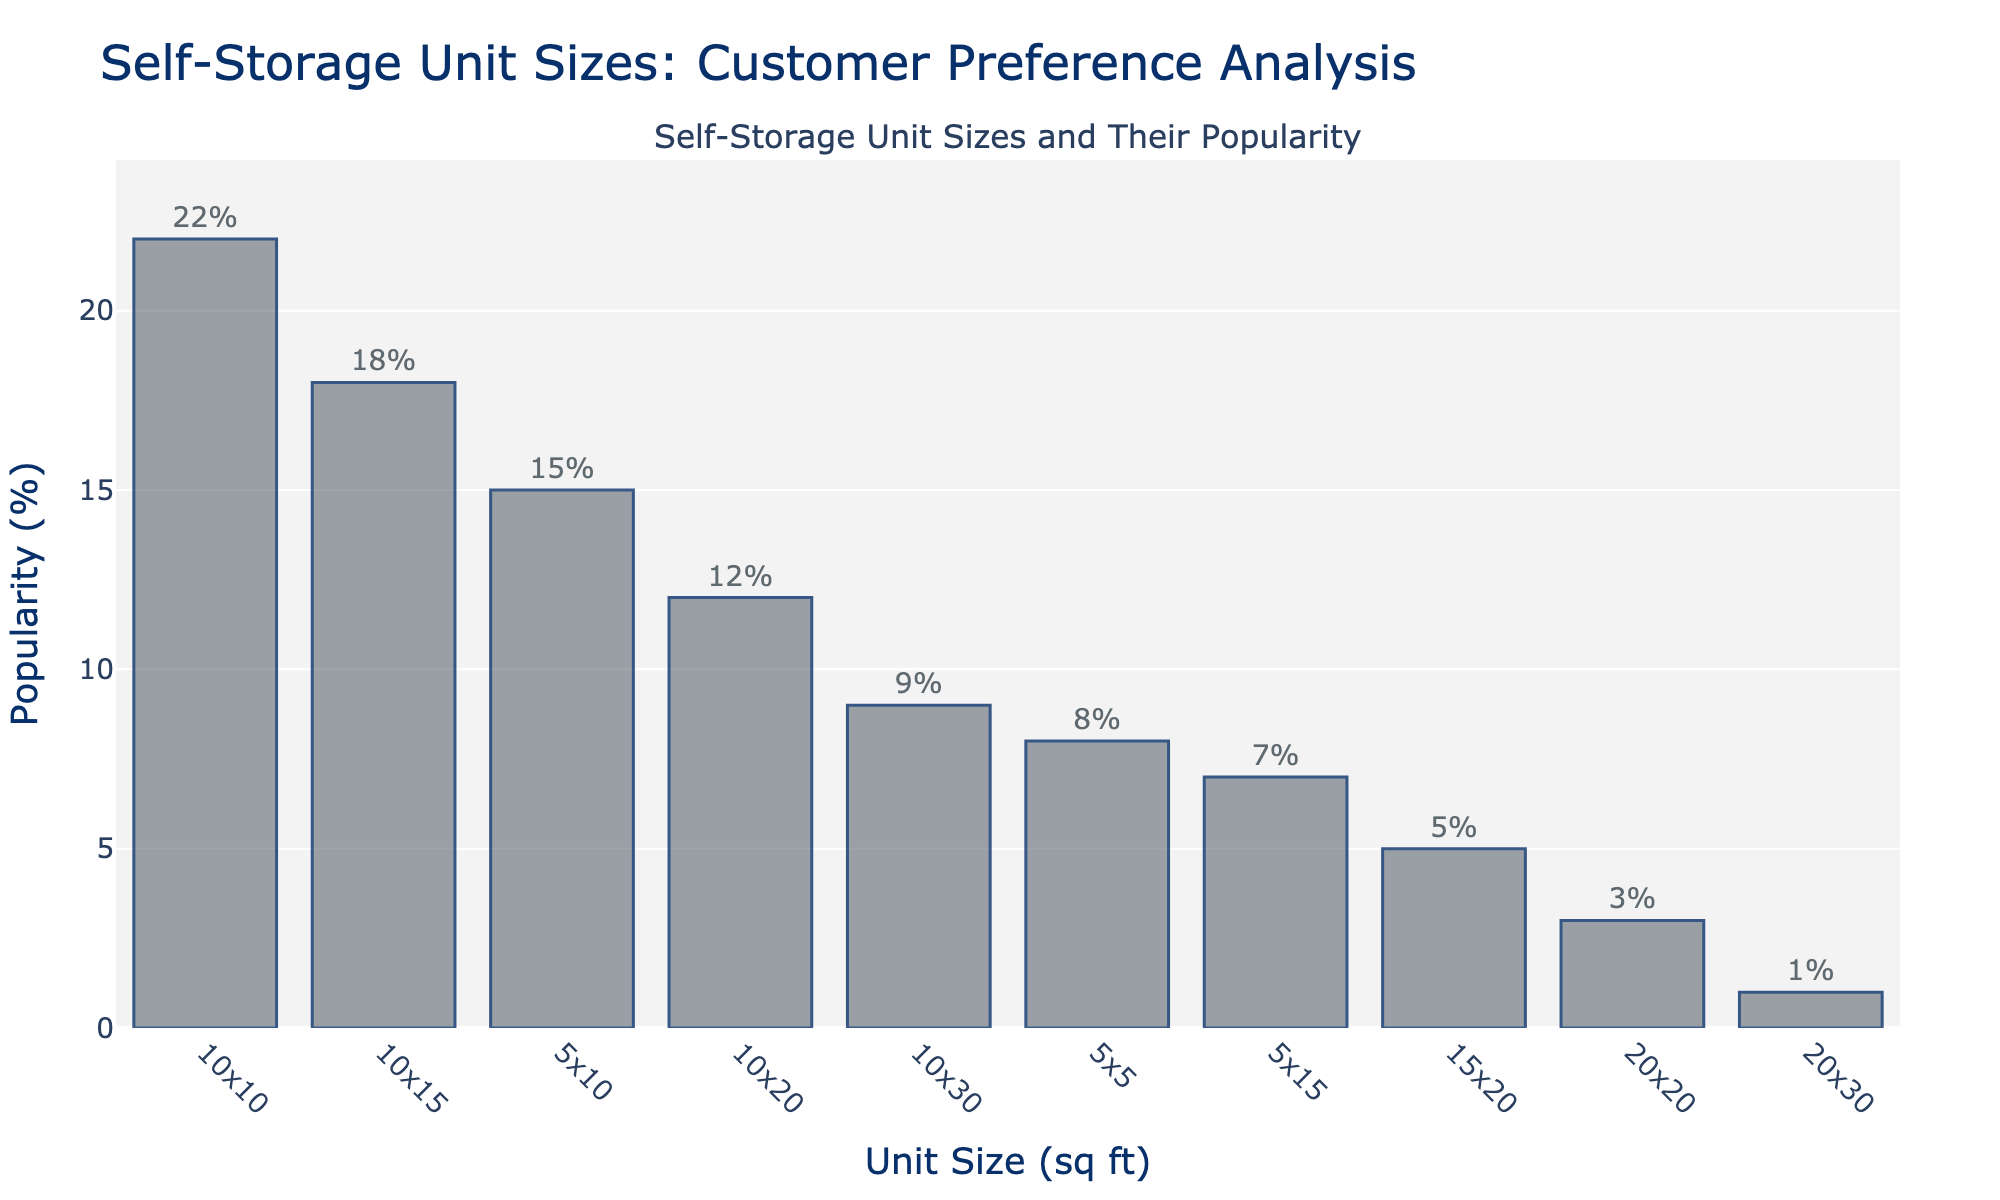What is the most popular self-storage unit size? The unit size with the highest bar represents the most popular self-storage unit size. By observing the chart, the 10x10 unit size has the highest bar.
Answer: 10x10 What is the least popular self-storage unit size? The unit size with the shortest bar indicates the least popular unit size. By observing the chart, the 20x30 unit size has the shortest bar.
Answer: 20x30 How much more popular is the 10x10 unit size compared to the 20x20 unit size? Identify the bars for the 10x10 and 20x20 unit sizes. The 10x10 unit size has 22%, and the 20x20 unit size has 3%. The difference is 22% - 3% = 19%.
Answer: 19% Which unit size has a popularity of 9%? Look for the bar with a height corresponding to 9%. The chart indicates that the 10x30 unit size has a popularity of 9%.
Answer: 10x30 What is the combined popularity percentage of the 5x5 and 10x20 unit sizes? Identify the popularity percentages for the 5x5 and 10x20 unit sizes, which are 8% and 12%, respectively. Add these percentages: 8% + 12% = 20%.
Answer: 20% Are any unit sizes equally popular, and if so, which ones? Examine the bars and check for equal heights. No bars have equal heights, so no unit sizes have exactly the same popularity.
Answer: No How does the popularity of the 5x10 unit size compare to the 10x15 unit size? Compare the heights of the bars for the 5x10 and 10x15 unit sizes. The 5x10 unit size has a popularity of 15%, while the 10x15 unit size has 18%. The 10x15 unit size is more popular than the 5x10 unit size.
Answer: 10x15 is more popular What is the average popularity percentage of the 5x10, 10x10, and 5x15 unit sizes? Find the popularity percentages for the 5x10 (15%), 10x10 (22%), and 5x15 (7%). Calculate the average: (15% + 22% + 7%) / 3 = 14.67%.
Answer: 14.67% Which unit size is less popular, the 10x20 or the 5x10? Compare the heights of the bars for the 10x20 (12%) and 5x10 (15%). The 10x20 unit size is less popular than the 5x10 unit size.
Answer: 10x20 How many unit sizes have a popularity of 10% or more? Count the number of bars with a height of 10% or more. The unit sizes are 5x10, 10x10, 10x15, and 10x20, making a total of 4 unit sizes.
Answer: 4 